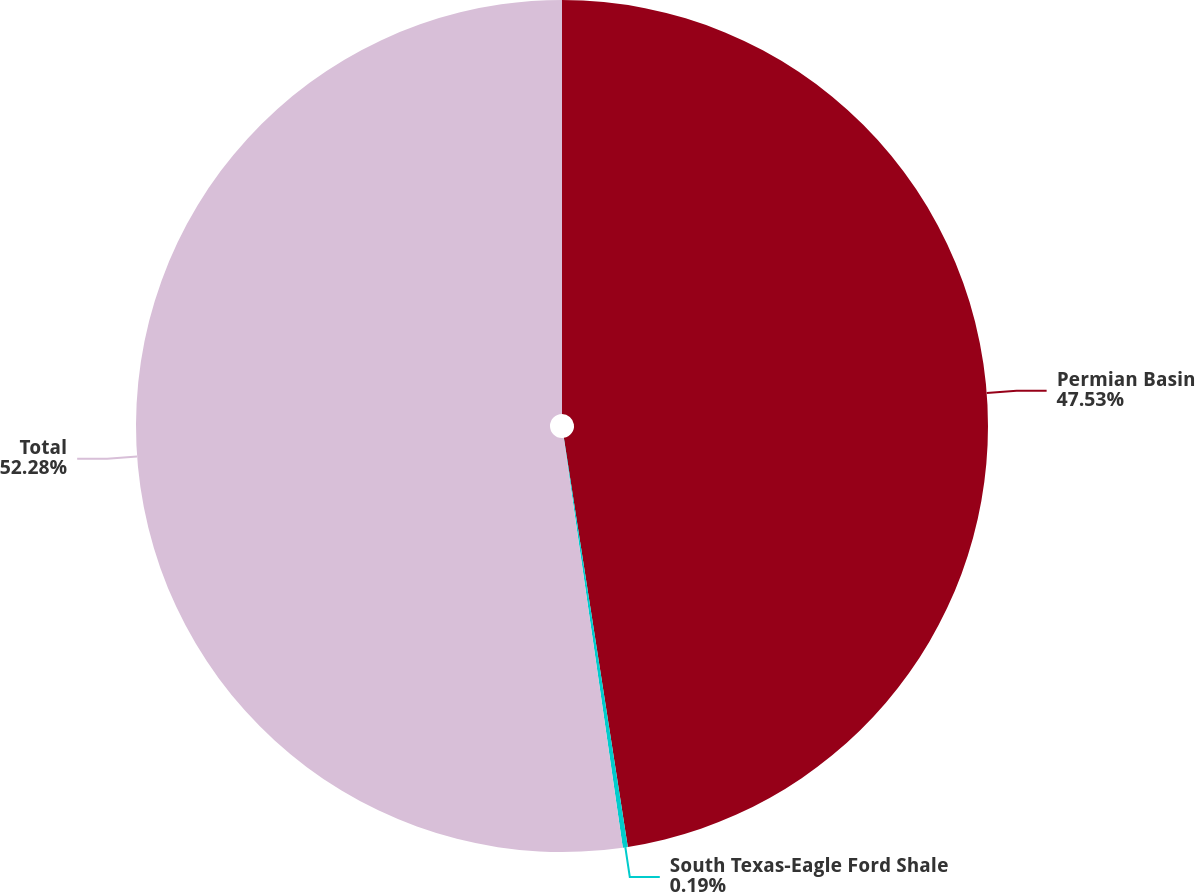<chart> <loc_0><loc_0><loc_500><loc_500><pie_chart><fcel>Permian Basin<fcel>South Texas-Eagle Ford Shale<fcel>Total<nl><fcel>47.53%<fcel>0.19%<fcel>52.28%<nl></chart> 